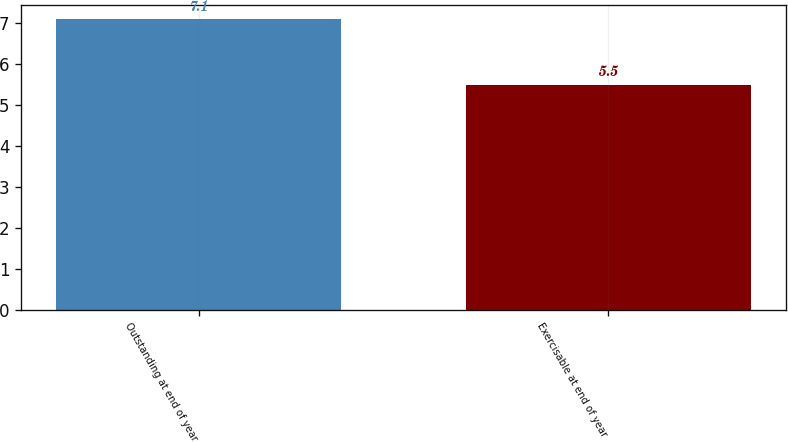Convert chart. <chart><loc_0><loc_0><loc_500><loc_500><bar_chart><fcel>Outstanding at end of year<fcel>Exercisable at end of year<nl><fcel>7.1<fcel>5.5<nl></chart> 